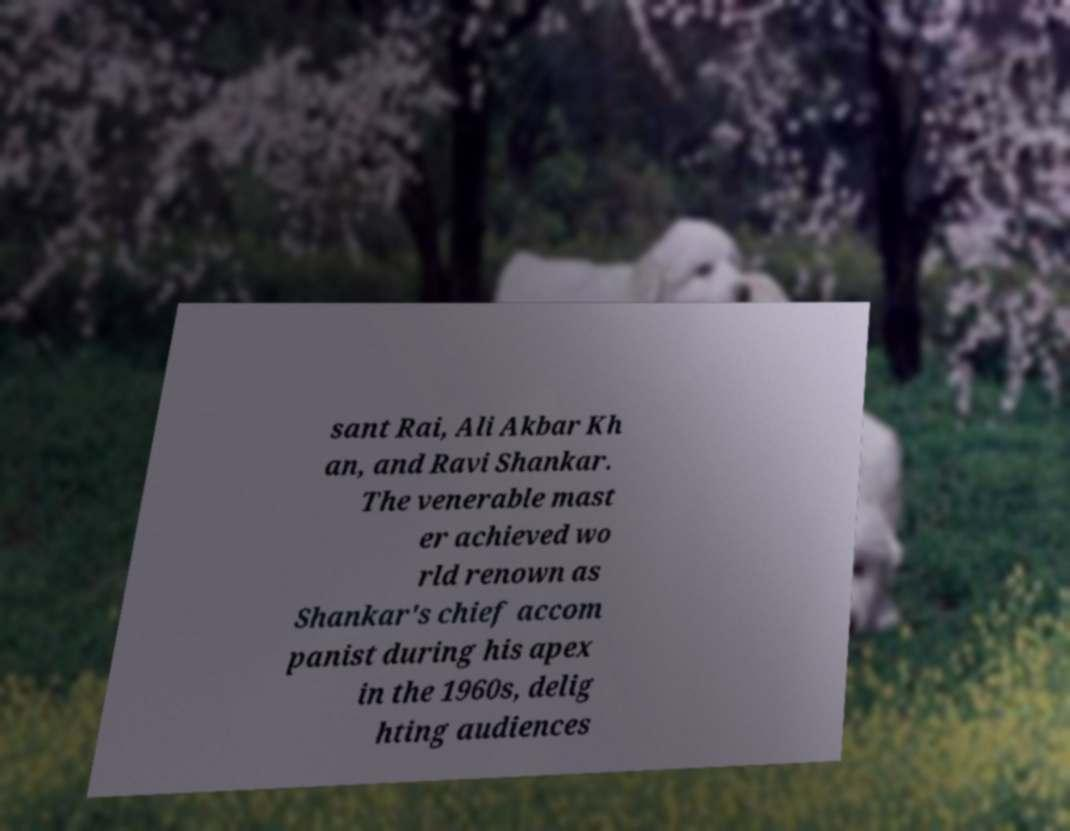Could you assist in decoding the text presented in this image and type it out clearly? sant Rai, Ali Akbar Kh an, and Ravi Shankar. The venerable mast er achieved wo rld renown as Shankar's chief accom panist during his apex in the 1960s, delig hting audiences 